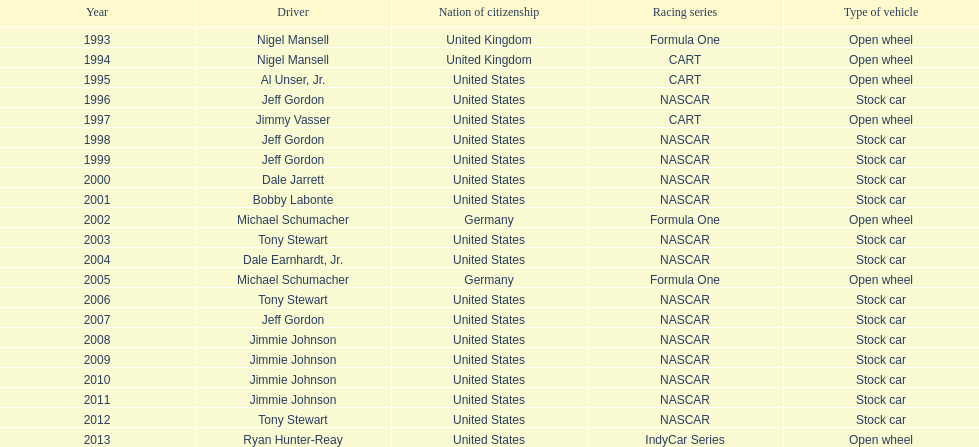How many espy awards did jimmy johnson win in a row? 4. 